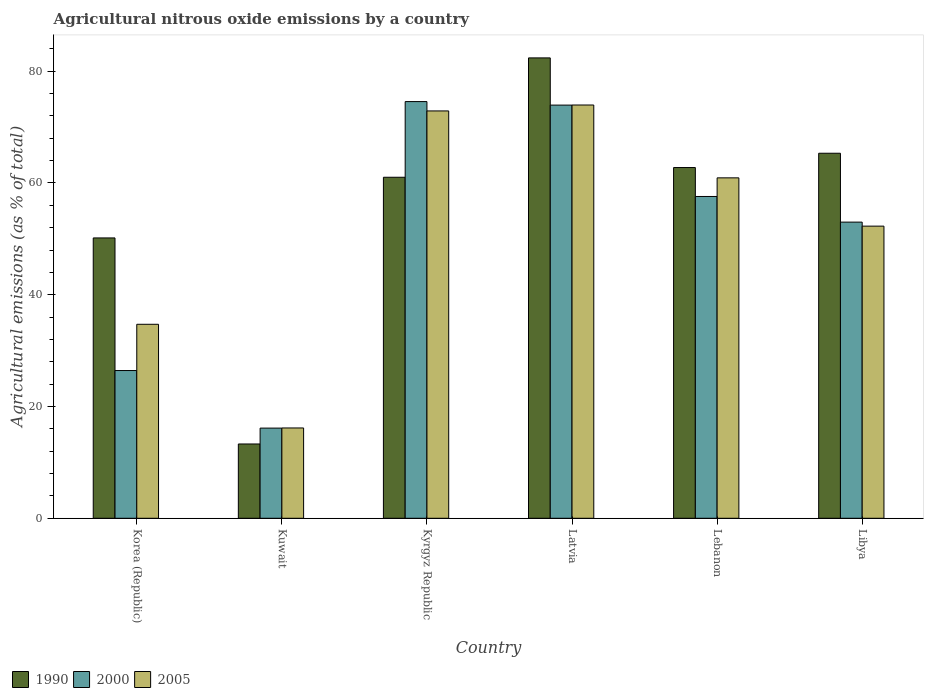How many groups of bars are there?
Provide a short and direct response. 6. Are the number of bars on each tick of the X-axis equal?
Make the answer very short. Yes. How many bars are there on the 1st tick from the right?
Your answer should be very brief. 3. What is the label of the 2nd group of bars from the left?
Your answer should be compact. Kuwait. In how many cases, is the number of bars for a given country not equal to the number of legend labels?
Offer a very short reply. 0. What is the amount of agricultural nitrous oxide emitted in 2000 in Kuwait?
Your answer should be very brief. 16.13. Across all countries, what is the maximum amount of agricultural nitrous oxide emitted in 1990?
Offer a very short reply. 82.37. Across all countries, what is the minimum amount of agricultural nitrous oxide emitted in 2000?
Make the answer very short. 16.13. In which country was the amount of agricultural nitrous oxide emitted in 2005 maximum?
Make the answer very short. Latvia. In which country was the amount of agricultural nitrous oxide emitted in 2000 minimum?
Offer a very short reply. Kuwait. What is the total amount of agricultural nitrous oxide emitted in 1990 in the graph?
Ensure brevity in your answer.  334.91. What is the difference between the amount of agricultural nitrous oxide emitted in 2005 in Korea (Republic) and that in Kuwait?
Offer a terse response. 18.55. What is the difference between the amount of agricultural nitrous oxide emitted in 2000 in Kuwait and the amount of agricultural nitrous oxide emitted in 2005 in Korea (Republic)?
Provide a succinct answer. -18.57. What is the average amount of agricultural nitrous oxide emitted in 2005 per country?
Your answer should be very brief. 51.81. What is the difference between the amount of agricultural nitrous oxide emitted of/in 1990 and amount of agricultural nitrous oxide emitted of/in 2005 in Latvia?
Make the answer very short. 8.43. In how many countries, is the amount of agricultural nitrous oxide emitted in 2005 greater than 16 %?
Keep it short and to the point. 6. What is the ratio of the amount of agricultural nitrous oxide emitted in 2005 in Latvia to that in Libya?
Keep it short and to the point. 1.41. What is the difference between the highest and the second highest amount of agricultural nitrous oxide emitted in 1990?
Provide a succinct answer. -17.06. What is the difference between the highest and the lowest amount of agricultural nitrous oxide emitted in 2000?
Your answer should be very brief. 58.42. Is the sum of the amount of agricultural nitrous oxide emitted in 2000 in Korea (Republic) and Kuwait greater than the maximum amount of agricultural nitrous oxide emitted in 2005 across all countries?
Give a very brief answer. No. What does the 1st bar from the left in Lebanon represents?
Offer a very short reply. 1990. Are the values on the major ticks of Y-axis written in scientific E-notation?
Offer a terse response. No. Does the graph contain any zero values?
Make the answer very short. No. Where does the legend appear in the graph?
Provide a short and direct response. Bottom left. How many legend labels are there?
Your response must be concise. 3. What is the title of the graph?
Provide a short and direct response. Agricultural nitrous oxide emissions by a country. Does "1983" appear as one of the legend labels in the graph?
Offer a terse response. No. What is the label or title of the X-axis?
Your answer should be compact. Country. What is the label or title of the Y-axis?
Provide a short and direct response. Agricultural emissions (as % of total). What is the Agricultural emissions (as % of total) of 1990 in Korea (Republic)?
Provide a short and direct response. 50.16. What is the Agricultural emissions (as % of total) of 2000 in Korea (Republic)?
Offer a terse response. 26.43. What is the Agricultural emissions (as % of total) of 2005 in Korea (Republic)?
Your response must be concise. 34.71. What is the Agricultural emissions (as % of total) of 1990 in Kuwait?
Keep it short and to the point. 13.29. What is the Agricultural emissions (as % of total) in 2000 in Kuwait?
Your answer should be very brief. 16.13. What is the Agricultural emissions (as % of total) of 2005 in Kuwait?
Give a very brief answer. 16.16. What is the Agricultural emissions (as % of total) in 1990 in Kyrgyz Republic?
Give a very brief answer. 61.01. What is the Agricultural emissions (as % of total) in 2000 in Kyrgyz Republic?
Provide a succinct answer. 74.56. What is the Agricultural emissions (as % of total) in 2005 in Kyrgyz Republic?
Make the answer very short. 72.88. What is the Agricultural emissions (as % of total) in 1990 in Latvia?
Your response must be concise. 82.37. What is the Agricultural emissions (as % of total) in 2000 in Latvia?
Your answer should be compact. 73.93. What is the Agricultural emissions (as % of total) of 2005 in Latvia?
Your answer should be very brief. 73.94. What is the Agricultural emissions (as % of total) of 1990 in Lebanon?
Ensure brevity in your answer.  62.76. What is the Agricultural emissions (as % of total) in 2000 in Lebanon?
Make the answer very short. 57.58. What is the Agricultural emissions (as % of total) in 2005 in Lebanon?
Give a very brief answer. 60.91. What is the Agricultural emissions (as % of total) of 1990 in Libya?
Make the answer very short. 65.31. What is the Agricultural emissions (as % of total) in 2000 in Libya?
Give a very brief answer. 52.99. What is the Agricultural emissions (as % of total) in 2005 in Libya?
Offer a very short reply. 52.27. Across all countries, what is the maximum Agricultural emissions (as % of total) in 1990?
Offer a terse response. 82.37. Across all countries, what is the maximum Agricultural emissions (as % of total) in 2000?
Offer a very short reply. 74.56. Across all countries, what is the maximum Agricultural emissions (as % of total) of 2005?
Offer a very short reply. 73.94. Across all countries, what is the minimum Agricultural emissions (as % of total) of 1990?
Offer a terse response. 13.29. Across all countries, what is the minimum Agricultural emissions (as % of total) in 2000?
Your response must be concise. 16.13. Across all countries, what is the minimum Agricultural emissions (as % of total) in 2005?
Keep it short and to the point. 16.16. What is the total Agricultural emissions (as % of total) in 1990 in the graph?
Provide a succinct answer. 334.91. What is the total Agricultural emissions (as % of total) in 2000 in the graph?
Provide a short and direct response. 301.62. What is the total Agricultural emissions (as % of total) of 2005 in the graph?
Offer a terse response. 310.88. What is the difference between the Agricultural emissions (as % of total) of 1990 in Korea (Republic) and that in Kuwait?
Provide a short and direct response. 36.87. What is the difference between the Agricultural emissions (as % of total) in 2000 in Korea (Republic) and that in Kuwait?
Your answer should be very brief. 10.3. What is the difference between the Agricultural emissions (as % of total) in 2005 in Korea (Republic) and that in Kuwait?
Your response must be concise. 18.55. What is the difference between the Agricultural emissions (as % of total) in 1990 in Korea (Republic) and that in Kyrgyz Republic?
Offer a terse response. -10.86. What is the difference between the Agricultural emissions (as % of total) of 2000 in Korea (Republic) and that in Kyrgyz Republic?
Ensure brevity in your answer.  -48.12. What is the difference between the Agricultural emissions (as % of total) of 2005 in Korea (Republic) and that in Kyrgyz Republic?
Make the answer very short. -38.18. What is the difference between the Agricultural emissions (as % of total) of 1990 in Korea (Republic) and that in Latvia?
Offer a terse response. -32.21. What is the difference between the Agricultural emissions (as % of total) in 2000 in Korea (Republic) and that in Latvia?
Make the answer very short. -47.49. What is the difference between the Agricultural emissions (as % of total) of 2005 in Korea (Republic) and that in Latvia?
Your response must be concise. -39.23. What is the difference between the Agricultural emissions (as % of total) of 1990 in Korea (Republic) and that in Lebanon?
Ensure brevity in your answer.  -12.6. What is the difference between the Agricultural emissions (as % of total) of 2000 in Korea (Republic) and that in Lebanon?
Your response must be concise. -31.15. What is the difference between the Agricultural emissions (as % of total) in 2005 in Korea (Republic) and that in Lebanon?
Give a very brief answer. -26.2. What is the difference between the Agricultural emissions (as % of total) of 1990 in Korea (Republic) and that in Libya?
Provide a succinct answer. -15.15. What is the difference between the Agricultural emissions (as % of total) in 2000 in Korea (Republic) and that in Libya?
Your answer should be compact. -26.56. What is the difference between the Agricultural emissions (as % of total) in 2005 in Korea (Republic) and that in Libya?
Offer a very short reply. -17.56. What is the difference between the Agricultural emissions (as % of total) in 1990 in Kuwait and that in Kyrgyz Republic?
Keep it short and to the point. -47.72. What is the difference between the Agricultural emissions (as % of total) of 2000 in Kuwait and that in Kyrgyz Republic?
Give a very brief answer. -58.42. What is the difference between the Agricultural emissions (as % of total) in 2005 in Kuwait and that in Kyrgyz Republic?
Provide a succinct answer. -56.73. What is the difference between the Agricultural emissions (as % of total) of 1990 in Kuwait and that in Latvia?
Make the answer very short. -69.08. What is the difference between the Agricultural emissions (as % of total) of 2000 in Kuwait and that in Latvia?
Make the answer very short. -57.79. What is the difference between the Agricultural emissions (as % of total) of 2005 in Kuwait and that in Latvia?
Offer a very short reply. -57.79. What is the difference between the Agricultural emissions (as % of total) of 1990 in Kuwait and that in Lebanon?
Ensure brevity in your answer.  -49.46. What is the difference between the Agricultural emissions (as % of total) of 2000 in Kuwait and that in Lebanon?
Provide a short and direct response. -41.44. What is the difference between the Agricultural emissions (as % of total) in 2005 in Kuwait and that in Lebanon?
Your answer should be compact. -44.75. What is the difference between the Agricultural emissions (as % of total) in 1990 in Kuwait and that in Libya?
Your answer should be compact. -52.02. What is the difference between the Agricultural emissions (as % of total) in 2000 in Kuwait and that in Libya?
Your answer should be very brief. -36.85. What is the difference between the Agricultural emissions (as % of total) of 2005 in Kuwait and that in Libya?
Your response must be concise. -36.11. What is the difference between the Agricultural emissions (as % of total) in 1990 in Kyrgyz Republic and that in Latvia?
Offer a terse response. -21.36. What is the difference between the Agricultural emissions (as % of total) of 2000 in Kyrgyz Republic and that in Latvia?
Give a very brief answer. 0.63. What is the difference between the Agricultural emissions (as % of total) of 2005 in Kyrgyz Republic and that in Latvia?
Keep it short and to the point. -1.06. What is the difference between the Agricultural emissions (as % of total) of 1990 in Kyrgyz Republic and that in Lebanon?
Provide a short and direct response. -1.74. What is the difference between the Agricultural emissions (as % of total) of 2000 in Kyrgyz Republic and that in Lebanon?
Give a very brief answer. 16.98. What is the difference between the Agricultural emissions (as % of total) of 2005 in Kyrgyz Republic and that in Lebanon?
Your answer should be compact. 11.97. What is the difference between the Agricultural emissions (as % of total) in 1990 in Kyrgyz Republic and that in Libya?
Your response must be concise. -4.3. What is the difference between the Agricultural emissions (as % of total) in 2000 in Kyrgyz Republic and that in Libya?
Provide a short and direct response. 21.57. What is the difference between the Agricultural emissions (as % of total) in 2005 in Kyrgyz Republic and that in Libya?
Offer a terse response. 20.61. What is the difference between the Agricultural emissions (as % of total) in 1990 in Latvia and that in Lebanon?
Ensure brevity in your answer.  19.62. What is the difference between the Agricultural emissions (as % of total) of 2000 in Latvia and that in Lebanon?
Your response must be concise. 16.35. What is the difference between the Agricultural emissions (as % of total) in 2005 in Latvia and that in Lebanon?
Ensure brevity in your answer.  13.03. What is the difference between the Agricultural emissions (as % of total) in 1990 in Latvia and that in Libya?
Offer a very short reply. 17.06. What is the difference between the Agricultural emissions (as % of total) in 2000 in Latvia and that in Libya?
Your answer should be very brief. 20.94. What is the difference between the Agricultural emissions (as % of total) in 2005 in Latvia and that in Libya?
Provide a short and direct response. 21.67. What is the difference between the Agricultural emissions (as % of total) in 1990 in Lebanon and that in Libya?
Give a very brief answer. -2.56. What is the difference between the Agricultural emissions (as % of total) in 2000 in Lebanon and that in Libya?
Offer a very short reply. 4.59. What is the difference between the Agricultural emissions (as % of total) of 2005 in Lebanon and that in Libya?
Provide a succinct answer. 8.64. What is the difference between the Agricultural emissions (as % of total) of 1990 in Korea (Republic) and the Agricultural emissions (as % of total) of 2000 in Kuwait?
Your answer should be compact. 34.03. What is the difference between the Agricultural emissions (as % of total) in 1990 in Korea (Republic) and the Agricultural emissions (as % of total) in 2005 in Kuwait?
Ensure brevity in your answer.  34. What is the difference between the Agricultural emissions (as % of total) in 2000 in Korea (Republic) and the Agricultural emissions (as % of total) in 2005 in Kuwait?
Offer a terse response. 10.27. What is the difference between the Agricultural emissions (as % of total) of 1990 in Korea (Republic) and the Agricultural emissions (as % of total) of 2000 in Kyrgyz Republic?
Your answer should be compact. -24.4. What is the difference between the Agricultural emissions (as % of total) in 1990 in Korea (Republic) and the Agricultural emissions (as % of total) in 2005 in Kyrgyz Republic?
Offer a terse response. -22.72. What is the difference between the Agricultural emissions (as % of total) of 2000 in Korea (Republic) and the Agricultural emissions (as % of total) of 2005 in Kyrgyz Republic?
Your answer should be compact. -46.45. What is the difference between the Agricultural emissions (as % of total) of 1990 in Korea (Republic) and the Agricultural emissions (as % of total) of 2000 in Latvia?
Your answer should be compact. -23.77. What is the difference between the Agricultural emissions (as % of total) in 1990 in Korea (Republic) and the Agricultural emissions (as % of total) in 2005 in Latvia?
Make the answer very short. -23.78. What is the difference between the Agricultural emissions (as % of total) of 2000 in Korea (Republic) and the Agricultural emissions (as % of total) of 2005 in Latvia?
Make the answer very short. -47.51. What is the difference between the Agricultural emissions (as % of total) in 1990 in Korea (Republic) and the Agricultural emissions (as % of total) in 2000 in Lebanon?
Give a very brief answer. -7.42. What is the difference between the Agricultural emissions (as % of total) in 1990 in Korea (Republic) and the Agricultural emissions (as % of total) in 2005 in Lebanon?
Offer a terse response. -10.75. What is the difference between the Agricultural emissions (as % of total) of 2000 in Korea (Republic) and the Agricultural emissions (as % of total) of 2005 in Lebanon?
Provide a short and direct response. -34.48. What is the difference between the Agricultural emissions (as % of total) in 1990 in Korea (Republic) and the Agricultural emissions (as % of total) in 2000 in Libya?
Give a very brief answer. -2.83. What is the difference between the Agricultural emissions (as % of total) of 1990 in Korea (Republic) and the Agricultural emissions (as % of total) of 2005 in Libya?
Keep it short and to the point. -2.11. What is the difference between the Agricultural emissions (as % of total) of 2000 in Korea (Republic) and the Agricultural emissions (as % of total) of 2005 in Libya?
Ensure brevity in your answer.  -25.84. What is the difference between the Agricultural emissions (as % of total) of 1990 in Kuwait and the Agricultural emissions (as % of total) of 2000 in Kyrgyz Republic?
Offer a very short reply. -61.26. What is the difference between the Agricultural emissions (as % of total) in 1990 in Kuwait and the Agricultural emissions (as % of total) in 2005 in Kyrgyz Republic?
Keep it short and to the point. -59.59. What is the difference between the Agricultural emissions (as % of total) in 2000 in Kuwait and the Agricultural emissions (as % of total) in 2005 in Kyrgyz Republic?
Provide a succinct answer. -56.75. What is the difference between the Agricultural emissions (as % of total) in 1990 in Kuwait and the Agricultural emissions (as % of total) in 2000 in Latvia?
Keep it short and to the point. -60.63. What is the difference between the Agricultural emissions (as % of total) in 1990 in Kuwait and the Agricultural emissions (as % of total) in 2005 in Latvia?
Keep it short and to the point. -60.65. What is the difference between the Agricultural emissions (as % of total) in 2000 in Kuwait and the Agricultural emissions (as % of total) in 2005 in Latvia?
Make the answer very short. -57.81. What is the difference between the Agricultural emissions (as % of total) of 1990 in Kuwait and the Agricultural emissions (as % of total) of 2000 in Lebanon?
Provide a short and direct response. -44.29. What is the difference between the Agricultural emissions (as % of total) of 1990 in Kuwait and the Agricultural emissions (as % of total) of 2005 in Lebanon?
Your answer should be very brief. -47.62. What is the difference between the Agricultural emissions (as % of total) of 2000 in Kuwait and the Agricultural emissions (as % of total) of 2005 in Lebanon?
Keep it short and to the point. -44.78. What is the difference between the Agricultural emissions (as % of total) of 1990 in Kuwait and the Agricultural emissions (as % of total) of 2000 in Libya?
Provide a short and direct response. -39.7. What is the difference between the Agricultural emissions (as % of total) of 1990 in Kuwait and the Agricultural emissions (as % of total) of 2005 in Libya?
Keep it short and to the point. -38.98. What is the difference between the Agricultural emissions (as % of total) in 2000 in Kuwait and the Agricultural emissions (as % of total) in 2005 in Libya?
Your answer should be very brief. -36.13. What is the difference between the Agricultural emissions (as % of total) in 1990 in Kyrgyz Republic and the Agricultural emissions (as % of total) in 2000 in Latvia?
Provide a succinct answer. -12.91. What is the difference between the Agricultural emissions (as % of total) of 1990 in Kyrgyz Republic and the Agricultural emissions (as % of total) of 2005 in Latvia?
Your answer should be compact. -12.93. What is the difference between the Agricultural emissions (as % of total) of 2000 in Kyrgyz Republic and the Agricultural emissions (as % of total) of 2005 in Latvia?
Your response must be concise. 0.61. What is the difference between the Agricultural emissions (as % of total) in 1990 in Kyrgyz Republic and the Agricultural emissions (as % of total) in 2000 in Lebanon?
Give a very brief answer. 3.44. What is the difference between the Agricultural emissions (as % of total) in 1990 in Kyrgyz Republic and the Agricultural emissions (as % of total) in 2005 in Lebanon?
Make the answer very short. 0.1. What is the difference between the Agricultural emissions (as % of total) in 2000 in Kyrgyz Republic and the Agricultural emissions (as % of total) in 2005 in Lebanon?
Give a very brief answer. 13.65. What is the difference between the Agricultural emissions (as % of total) of 1990 in Kyrgyz Republic and the Agricultural emissions (as % of total) of 2000 in Libya?
Your answer should be compact. 8.03. What is the difference between the Agricultural emissions (as % of total) in 1990 in Kyrgyz Republic and the Agricultural emissions (as % of total) in 2005 in Libya?
Ensure brevity in your answer.  8.75. What is the difference between the Agricultural emissions (as % of total) in 2000 in Kyrgyz Republic and the Agricultural emissions (as % of total) in 2005 in Libya?
Your answer should be compact. 22.29. What is the difference between the Agricultural emissions (as % of total) of 1990 in Latvia and the Agricultural emissions (as % of total) of 2000 in Lebanon?
Your response must be concise. 24.8. What is the difference between the Agricultural emissions (as % of total) of 1990 in Latvia and the Agricultural emissions (as % of total) of 2005 in Lebanon?
Provide a short and direct response. 21.46. What is the difference between the Agricultural emissions (as % of total) in 2000 in Latvia and the Agricultural emissions (as % of total) in 2005 in Lebanon?
Your response must be concise. 13.02. What is the difference between the Agricultural emissions (as % of total) in 1990 in Latvia and the Agricultural emissions (as % of total) in 2000 in Libya?
Give a very brief answer. 29.38. What is the difference between the Agricultural emissions (as % of total) of 1990 in Latvia and the Agricultural emissions (as % of total) of 2005 in Libya?
Keep it short and to the point. 30.1. What is the difference between the Agricultural emissions (as % of total) in 2000 in Latvia and the Agricultural emissions (as % of total) in 2005 in Libya?
Your answer should be compact. 21.66. What is the difference between the Agricultural emissions (as % of total) of 1990 in Lebanon and the Agricultural emissions (as % of total) of 2000 in Libya?
Keep it short and to the point. 9.77. What is the difference between the Agricultural emissions (as % of total) of 1990 in Lebanon and the Agricultural emissions (as % of total) of 2005 in Libya?
Ensure brevity in your answer.  10.49. What is the difference between the Agricultural emissions (as % of total) of 2000 in Lebanon and the Agricultural emissions (as % of total) of 2005 in Libya?
Provide a succinct answer. 5.31. What is the average Agricultural emissions (as % of total) of 1990 per country?
Provide a succinct answer. 55.82. What is the average Agricultural emissions (as % of total) in 2000 per country?
Provide a succinct answer. 50.27. What is the average Agricultural emissions (as % of total) in 2005 per country?
Provide a short and direct response. 51.81. What is the difference between the Agricultural emissions (as % of total) of 1990 and Agricultural emissions (as % of total) of 2000 in Korea (Republic)?
Provide a short and direct response. 23.73. What is the difference between the Agricultural emissions (as % of total) of 1990 and Agricultural emissions (as % of total) of 2005 in Korea (Republic)?
Make the answer very short. 15.45. What is the difference between the Agricultural emissions (as % of total) in 2000 and Agricultural emissions (as % of total) in 2005 in Korea (Republic)?
Ensure brevity in your answer.  -8.28. What is the difference between the Agricultural emissions (as % of total) of 1990 and Agricultural emissions (as % of total) of 2000 in Kuwait?
Your answer should be compact. -2.84. What is the difference between the Agricultural emissions (as % of total) in 1990 and Agricultural emissions (as % of total) in 2005 in Kuwait?
Make the answer very short. -2.87. What is the difference between the Agricultural emissions (as % of total) of 2000 and Agricultural emissions (as % of total) of 2005 in Kuwait?
Provide a succinct answer. -0.02. What is the difference between the Agricultural emissions (as % of total) in 1990 and Agricultural emissions (as % of total) in 2000 in Kyrgyz Republic?
Give a very brief answer. -13.54. What is the difference between the Agricultural emissions (as % of total) in 1990 and Agricultural emissions (as % of total) in 2005 in Kyrgyz Republic?
Give a very brief answer. -11.87. What is the difference between the Agricultural emissions (as % of total) in 2000 and Agricultural emissions (as % of total) in 2005 in Kyrgyz Republic?
Your answer should be compact. 1.67. What is the difference between the Agricultural emissions (as % of total) of 1990 and Agricultural emissions (as % of total) of 2000 in Latvia?
Your response must be concise. 8.45. What is the difference between the Agricultural emissions (as % of total) in 1990 and Agricultural emissions (as % of total) in 2005 in Latvia?
Give a very brief answer. 8.43. What is the difference between the Agricultural emissions (as % of total) in 2000 and Agricultural emissions (as % of total) in 2005 in Latvia?
Make the answer very short. -0.02. What is the difference between the Agricultural emissions (as % of total) of 1990 and Agricultural emissions (as % of total) of 2000 in Lebanon?
Offer a terse response. 5.18. What is the difference between the Agricultural emissions (as % of total) in 1990 and Agricultural emissions (as % of total) in 2005 in Lebanon?
Give a very brief answer. 1.85. What is the difference between the Agricultural emissions (as % of total) of 2000 and Agricultural emissions (as % of total) of 2005 in Lebanon?
Provide a short and direct response. -3.33. What is the difference between the Agricultural emissions (as % of total) of 1990 and Agricultural emissions (as % of total) of 2000 in Libya?
Offer a terse response. 12.32. What is the difference between the Agricultural emissions (as % of total) in 1990 and Agricultural emissions (as % of total) in 2005 in Libya?
Give a very brief answer. 13.04. What is the difference between the Agricultural emissions (as % of total) in 2000 and Agricultural emissions (as % of total) in 2005 in Libya?
Make the answer very short. 0.72. What is the ratio of the Agricultural emissions (as % of total) of 1990 in Korea (Republic) to that in Kuwait?
Offer a terse response. 3.77. What is the ratio of the Agricultural emissions (as % of total) of 2000 in Korea (Republic) to that in Kuwait?
Your answer should be very brief. 1.64. What is the ratio of the Agricultural emissions (as % of total) of 2005 in Korea (Republic) to that in Kuwait?
Give a very brief answer. 2.15. What is the ratio of the Agricultural emissions (as % of total) of 1990 in Korea (Republic) to that in Kyrgyz Republic?
Your response must be concise. 0.82. What is the ratio of the Agricultural emissions (as % of total) of 2000 in Korea (Republic) to that in Kyrgyz Republic?
Your response must be concise. 0.35. What is the ratio of the Agricultural emissions (as % of total) of 2005 in Korea (Republic) to that in Kyrgyz Republic?
Provide a succinct answer. 0.48. What is the ratio of the Agricultural emissions (as % of total) of 1990 in Korea (Republic) to that in Latvia?
Your answer should be compact. 0.61. What is the ratio of the Agricultural emissions (as % of total) of 2000 in Korea (Republic) to that in Latvia?
Provide a succinct answer. 0.36. What is the ratio of the Agricultural emissions (as % of total) of 2005 in Korea (Republic) to that in Latvia?
Provide a succinct answer. 0.47. What is the ratio of the Agricultural emissions (as % of total) in 1990 in Korea (Republic) to that in Lebanon?
Make the answer very short. 0.8. What is the ratio of the Agricultural emissions (as % of total) of 2000 in Korea (Republic) to that in Lebanon?
Provide a succinct answer. 0.46. What is the ratio of the Agricultural emissions (as % of total) in 2005 in Korea (Republic) to that in Lebanon?
Make the answer very short. 0.57. What is the ratio of the Agricultural emissions (as % of total) of 1990 in Korea (Republic) to that in Libya?
Offer a terse response. 0.77. What is the ratio of the Agricultural emissions (as % of total) in 2000 in Korea (Republic) to that in Libya?
Keep it short and to the point. 0.5. What is the ratio of the Agricultural emissions (as % of total) in 2005 in Korea (Republic) to that in Libya?
Keep it short and to the point. 0.66. What is the ratio of the Agricultural emissions (as % of total) in 1990 in Kuwait to that in Kyrgyz Republic?
Provide a short and direct response. 0.22. What is the ratio of the Agricultural emissions (as % of total) in 2000 in Kuwait to that in Kyrgyz Republic?
Give a very brief answer. 0.22. What is the ratio of the Agricultural emissions (as % of total) in 2005 in Kuwait to that in Kyrgyz Republic?
Provide a short and direct response. 0.22. What is the ratio of the Agricultural emissions (as % of total) of 1990 in Kuwait to that in Latvia?
Ensure brevity in your answer.  0.16. What is the ratio of the Agricultural emissions (as % of total) of 2000 in Kuwait to that in Latvia?
Ensure brevity in your answer.  0.22. What is the ratio of the Agricultural emissions (as % of total) in 2005 in Kuwait to that in Latvia?
Give a very brief answer. 0.22. What is the ratio of the Agricultural emissions (as % of total) in 1990 in Kuwait to that in Lebanon?
Provide a succinct answer. 0.21. What is the ratio of the Agricultural emissions (as % of total) in 2000 in Kuwait to that in Lebanon?
Make the answer very short. 0.28. What is the ratio of the Agricultural emissions (as % of total) of 2005 in Kuwait to that in Lebanon?
Give a very brief answer. 0.27. What is the ratio of the Agricultural emissions (as % of total) in 1990 in Kuwait to that in Libya?
Make the answer very short. 0.2. What is the ratio of the Agricultural emissions (as % of total) in 2000 in Kuwait to that in Libya?
Offer a very short reply. 0.3. What is the ratio of the Agricultural emissions (as % of total) of 2005 in Kuwait to that in Libya?
Keep it short and to the point. 0.31. What is the ratio of the Agricultural emissions (as % of total) in 1990 in Kyrgyz Republic to that in Latvia?
Your answer should be very brief. 0.74. What is the ratio of the Agricultural emissions (as % of total) of 2000 in Kyrgyz Republic to that in Latvia?
Provide a short and direct response. 1.01. What is the ratio of the Agricultural emissions (as % of total) of 2005 in Kyrgyz Republic to that in Latvia?
Ensure brevity in your answer.  0.99. What is the ratio of the Agricultural emissions (as % of total) of 1990 in Kyrgyz Republic to that in Lebanon?
Your response must be concise. 0.97. What is the ratio of the Agricultural emissions (as % of total) of 2000 in Kyrgyz Republic to that in Lebanon?
Your answer should be compact. 1.29. What is the ratio of the Agricultural emissions (as % of total) in 2005 in Kyrgyz Republic to that in Lebanon?
Your answer should be compact. 1.2. What is the ratio of the Agricultural emissions (as % of total) in 1990 in Kyrgyz Republic to that in Libya?
Make the answer very short. 0.93. What is the ratio of the Agricultural emissions (as % of total) in 2000 in Kyrgyz Republic to that in Libya?
Provide a succinct answer. 1.41. What is the ratio of the Agricultural emissions (as % of total) of 2005 in Kyrgyz Republic to that in Libya?
Your response must be concise. 1.39. What is the ratio of the Agricultural emissions (as % of total) in 1990 in Latvia to that in Lebanon?
Your answer should be compact. 1.31. What is the ratio of the Agricultural emissions (as % of total) in 2000 in Latvia to that in Lebanon?
Give a very brief answer. 1.28. What is the ratio of the Agricultural emissions (as % of total) in 2005 in Latvia to that in Lebanon?
Make the answer very short. 1.21. What is the ratio of the Agricultural emissions (as % of total) of 1990 in Latvia to that in Libya?
Your answer should be very brief. 1.26. What is the ratio of the Agricultural emissions (as % of total) of 2000 in Latvia to that in Libya?
Offer a terse response. 1.4. What is the ratio of the Agricultural emissions (as % of total) of 2005 in Latvia to that in Libya?
Make the answer very short. 1.41. What is the ratio of the Agricultural emissions (as % of total) in 1990 in Lebanon to that in Libya?
Ensure brevity in your answer.  0.96. What is the ratio of the Agricultural emissions (as % of total) of 2000 in Lebanon to that in Libya?
Make the answer very short. 1.09. What is the ratio of the Agricultural emissions (as % of total) of 2005 in Lebanon to that in Libya?
Your answer should be compact. 1.17. What is the difference between the highest and the second highest Agricultural emissions (as % of total) of 1990?
Your response must be concise. 17.06. What is the difference between the highest and the second highest Agricultural emissions (as % of total) in 2000?
Keep it short and to the point. 0.63. What is the difference between the highest and the second highest Agricultural emissions (as % of total) in 2005?
Your answer should be compact. 1.06. What is the difference between the highest and the lowest Agricultural emissions (as % of total) of 1990?
Offer a very short reply. 69.08. What is the difference between the highest and the lowest Agricultural emissions (as % of total) of 2000?
Keep it short and to the point. 58.42. What is the difference between the highest and the lowest Agricultural emissions (as % of total) in 2005?
Offer a terse response. 57.79. 